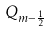Convert formula to latex. <formula><loc_0><loc_0><loc_500><loc_500>Q _ { m - \frac { 1 } { 2 } }</formula> 